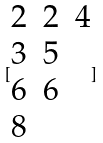<formula> <loc_0><loc_0><loc_500><loc_500>[ \begin{matrix} 2 & 2 & 4 \\ 3 & 5 \\ 6 & 6 \\ 8 \end{matrix} ]</formula> 